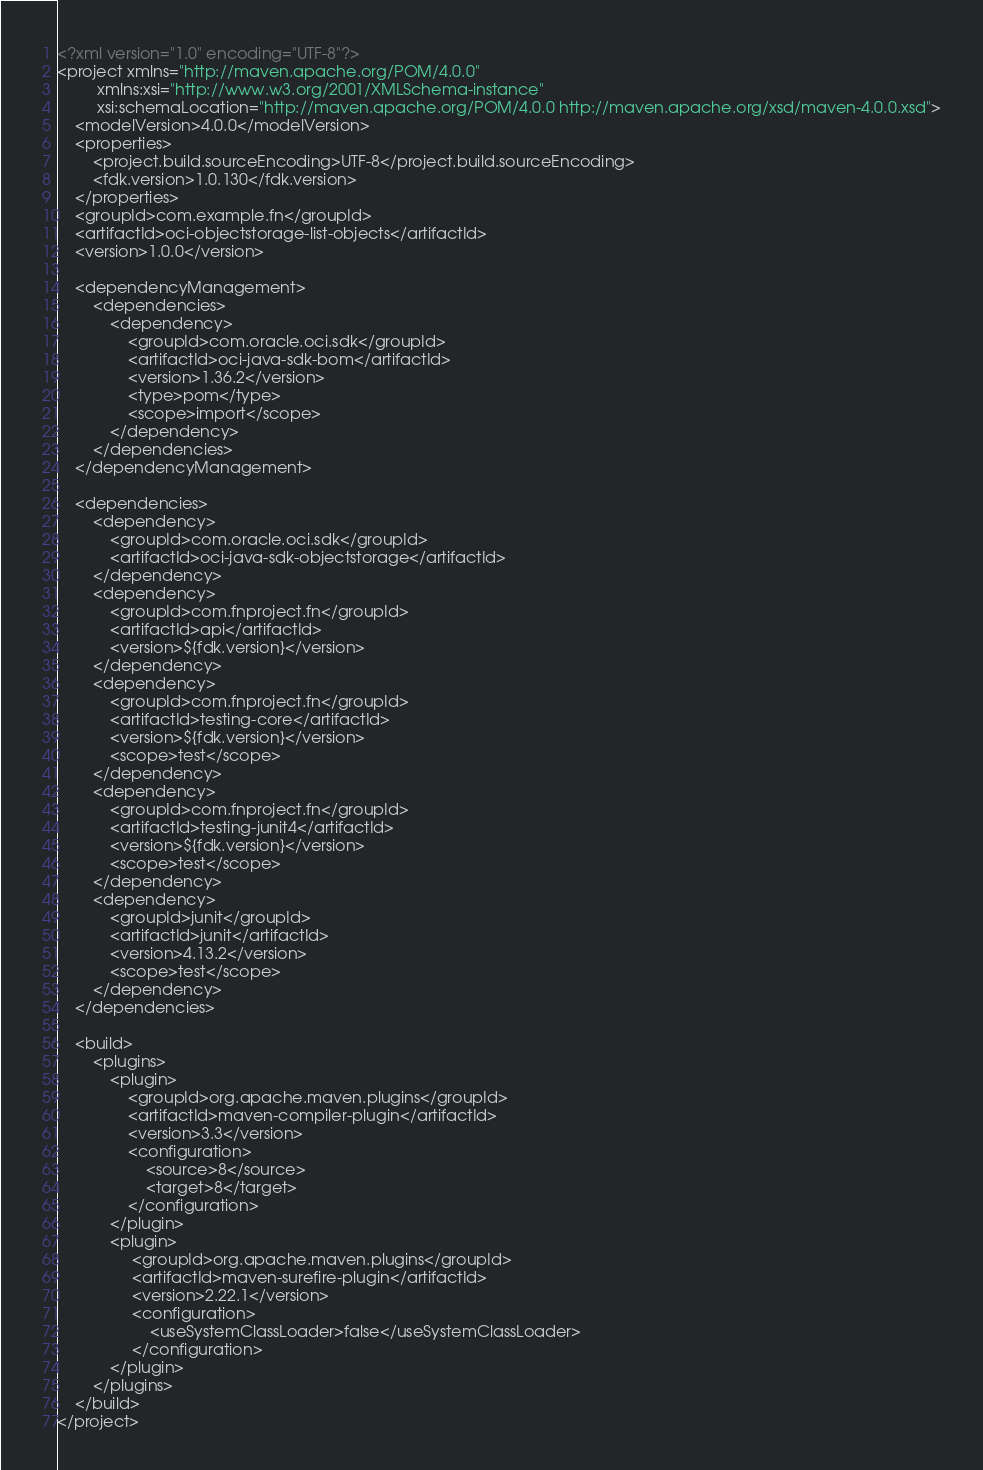Convert code to text. <code><loc_0><loc_0><loc_500><loc_500><_XML_><?xml version="1.0" encoding="UTF-8"?>
<project xmlns="http://maven.apache.org/POM/4.0.0"
         xmlns:xsi="http://www.w3.org/2001/XMLSchema-instance"
         xsi:schemaLocation="http://maven.apache.org/POM/4.0.0 http://maven.apache.org/xsd/maven-4.0.0.xsd">
    <modelVersion>4.0.0</modelVersion>
    <properties>
        <project.build.sourceEncoding>UTF-8</project.build.sourceEncoding>
        <fdk.version>1.0.130</fdk.version>
    </properties>
    <groupId>com.example.fn</groupId>
    <artifactId>oci-objectstorage-list-objects</artifactId>
    <version>1.0.0</version>

    <dependencyManagement>
        <dependencies>
            <dependency>
                <groupId>com.oracle.oci.sdk</groupId>
                <artifactId>oci-java-sdk-bom</artifactId>
                <version>1.36.2</version>
                <type>pom</type>
                <scope>import</scope>
            </dependency>
        </dependencies>
    </dependencyManagement>

    <dependencies>
        <dependency>
            <groupId>com.oracle.oci.sdk</groupId>
            <artifactId>oci-java-sdk-objectstorage</artifactId>
        </dependency>
        <dependency>
            <groupId>com.fnproject.fn</groupId>
            <artifactId>api</artifactId>
            <version>${fdk.version}</version>
        </dependency>
        <dependency>
            <groupId>com.fnproject.fn</groupId>
            <artifactId>testing-core</artifactId>
            <version>${fdk.version}</version>
            <scope>test</scope>
        </dependency>
        <dependency>
            <groupId>com.fnproject.fn</groupId>
            <artifactId>testing-junit4</artifactId>
            <version>${fdk.version}</version>
            <scope>test</scope>
        </dependency>
        <dependency>
            <groupId>junit</groupId>
            <artifactId>junit</artifactId>
            <version>4.13.2</version>
            <scope>test</scope>
        </dependency>
    </dependencies>

    <build>
        <plugins>
            <plugin>
                <groupId>org.apache.maven.plugins</groupId>
                <artifactId>maven-compiler-plugin</artifactId>
                <version>3.3</version>
                <configuration>
                    <source>8</source>
                    <target>8</target>
                </configuration>
            </plugin>
            <plugin>
                 <groupId>org.apache.maven.plugins</groupId>
                 <artifactId>maven-surefire-plugin</artifactId>
                 <version>2.22.1</version>
                 <configuration>
                     <useSystemClassLoader>false</useSystemClassLoader>
                 </configuration>
            </plugin>
        </plugins>
    </build>
</project>
</code> 